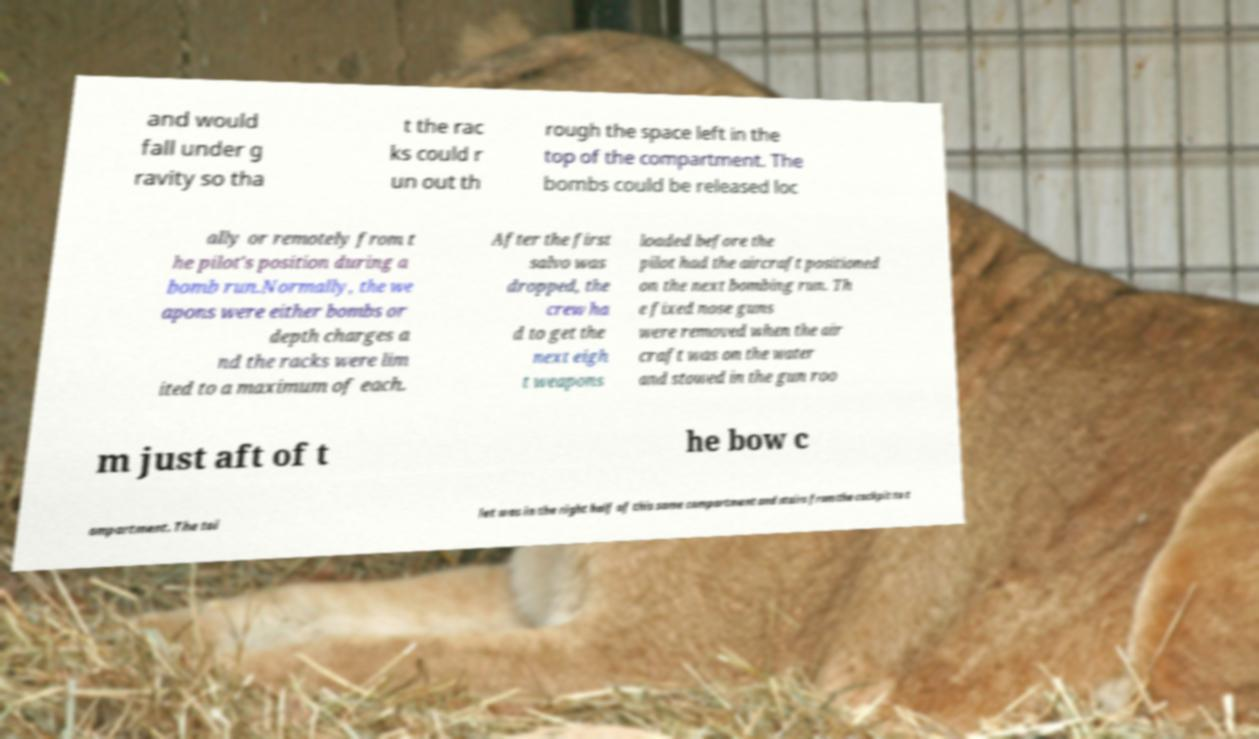Could you assist in decoding the text presented in this image and type it out clearly? and would fall under g ravity so tha t the rac ks could r un out th rough the space left in the top of the compartment. The bombs could be released loc ally or remotely from t he pilot's position during a bomb run.Normally, the we apons were either bombs or depth charges a nd the racks were lim ited to a maximum of each. After the first salvo was dropped, the crew ha d to get the next eigh t weapons loaded before the pilot had the aircraft positioned on the next bombing run. Th e fixed nose guns were removed when the air craft was on the water and stowed in the gun roo m just aft of t he bow c ompartment. The toi let was in the right half of this same compartment and stairs from the cockpit to t 